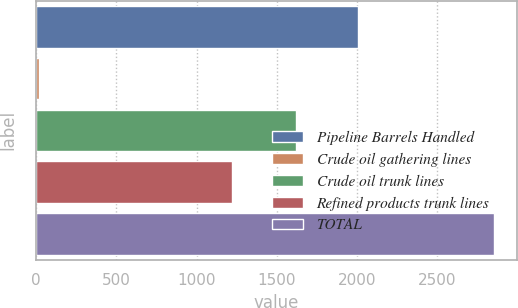Convert chart. <chart><loc_0><loc_0><loc_500><loc_500><bar_chart><fcel>Pipeline Barrels Handled<fcel>Crude oil gathering lines<fcel>Crude oil trunk lines<fcel>Refined products trunk lines<fcel>TOTAL<nl><fcel>2005<fcel>18<fcel>1619<fcel>1219<fcel>2856<nl></chart> 